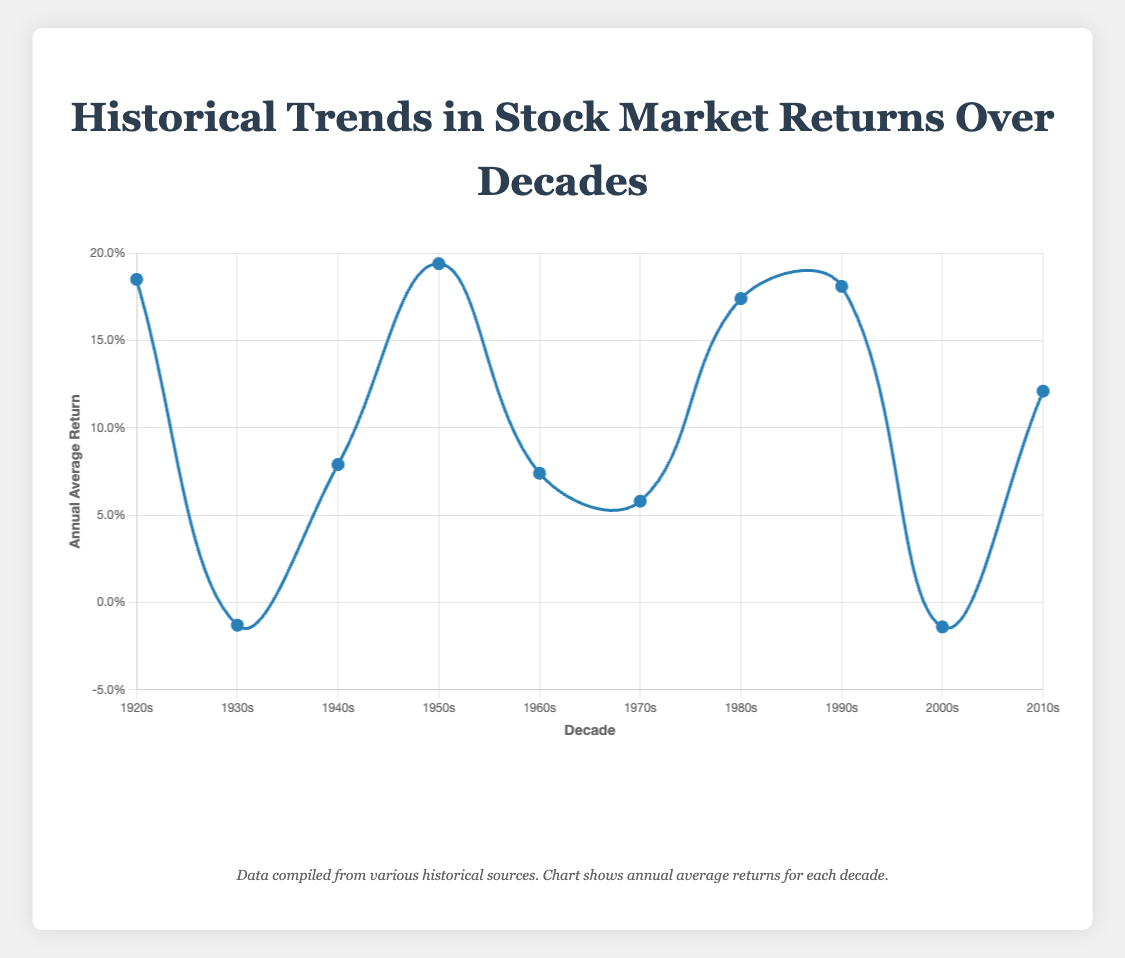What decade had the highest annual average return? By looking at the plot, the peak point can be identified visually. The highest point on the curve represents the highest return. The 1950s has the highest annual average return.
Answer: 1950s How does the average annual return in the 2000s compare to the 1980s? Identify the points for the 1980s and the 2000s. The 1980s have a positive return (0.174) while the 2000s have a negative return (-0.014). Comparatively, the 1980s return is significantly higher.
Answer: 1980s higher What is the difference between the annual average returns of the 1920s and the 1930s? Subtract the annual average return of the 1930s from that of the 1920s: 0.185 - (-0.013) = 0.198.
Answer: 0.198 Which decade had a better annual average return, the 1960s or the 1970s? Comparing the two values, the 1960s had an annual average return of 0.074, while the 1970s had 0.058. Therefore, the 1960s had a better return.
Answer: 1960s Which decade had the lowest annual average return? By identifying the lowest point on the curve, we can see the 2000s with an annual average return of -0.014.
Answer: 2000s What is the trend in annual average returns from the 1940s to the 1950s? Observe the direction of the curve between the 1940s and the 1950s. The annual average return increases from 0.079 in the 1940s to 0.194 in the 1950s.
Answer: Increase What is the average of the annual average returns of the 1980s and the 1990s? Calculate the average by summing the two returns and dividing by two: (0.174 + 0.181) / 2 = 0.1775.
Answer: 0.1775 What notable events might explain the low returns during the 1930s? The tooltip in the plot mentions the Great Depression and the Stock Market Crash of 1929 as notable events during the 1930s that likely contributed to the low returns.
Answer: Great Depression, Stock Market Crash of 1929 How much higher was the return in the 1950s compared to the 2010s? Subtract the annual average return of the 2010s from that of the 1950s: 0.194 - 0.121 = 0.073.
Answer: 0.073 